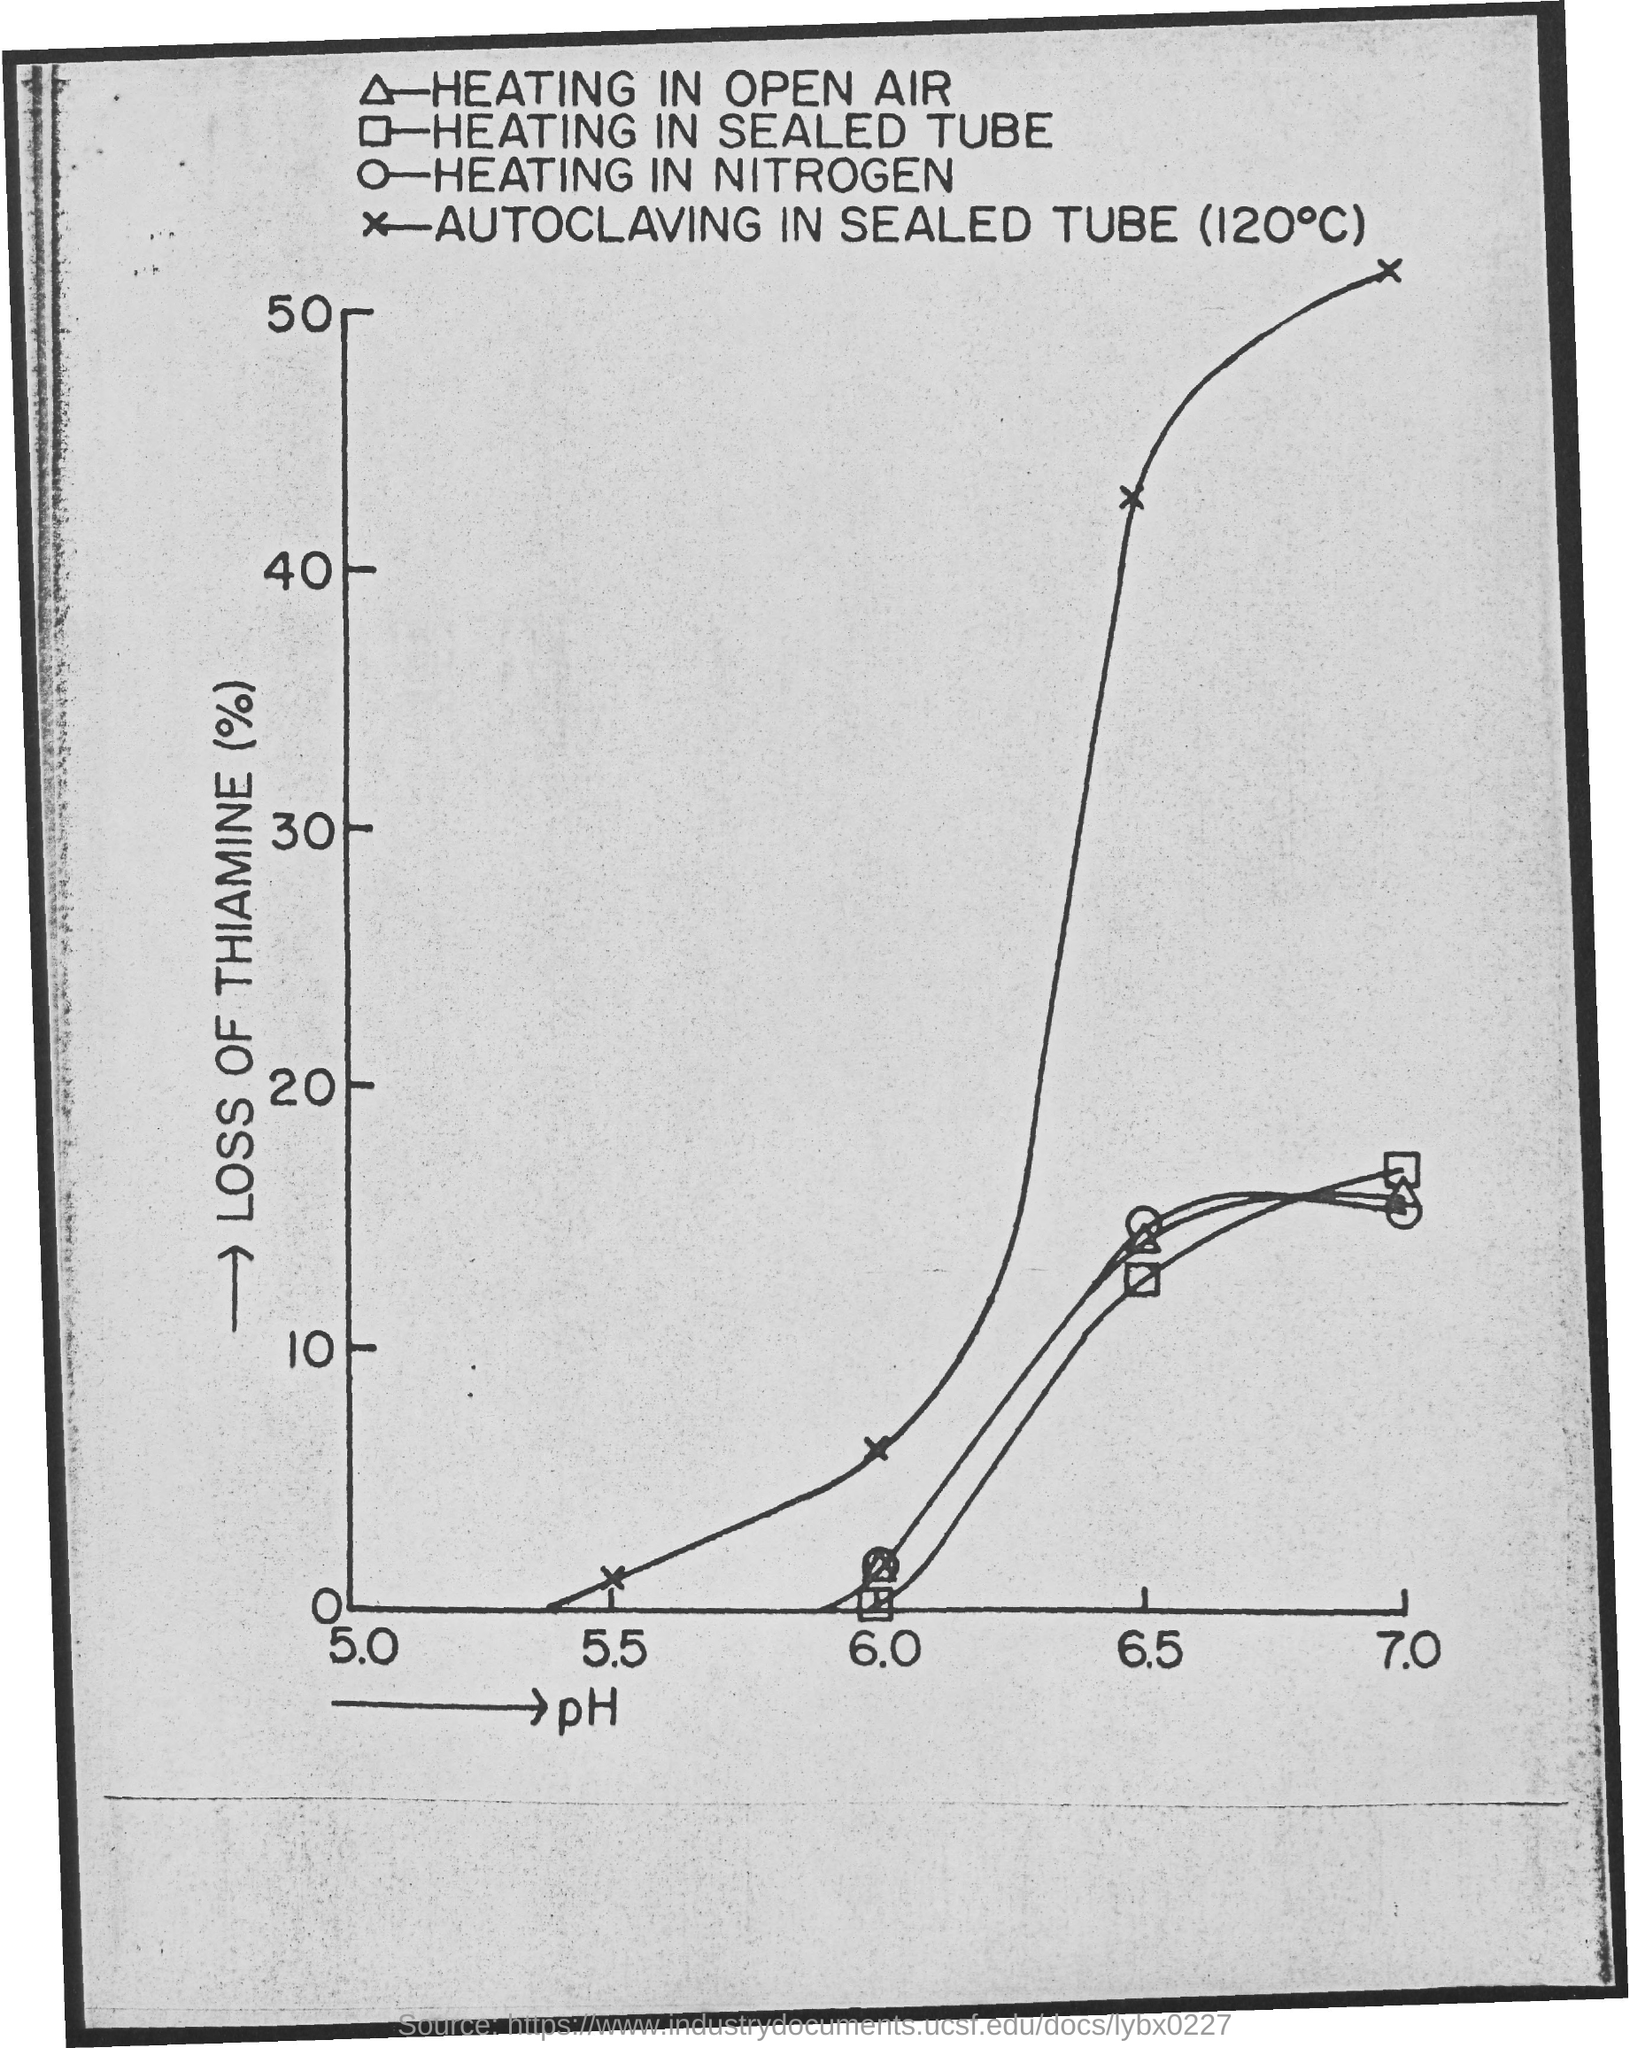Point out several critical features in this image. The pH value is mentioned on the x-axis of the graph. The maximum "Loss of Thiamine (%)" value on the y-axis of the graph is 50%. The pH value on the x-axis of the graph is 7.0 and the maximum pH value mentioned on the graph is 7.0. The minimum loss of thiamine (%), as shown on the y-axis of the graph, is 0 to 100%. The loss of thiamine, expressed as a percentage, in "HEATING IN SEALED TUBE" with a pH of 6.0. 